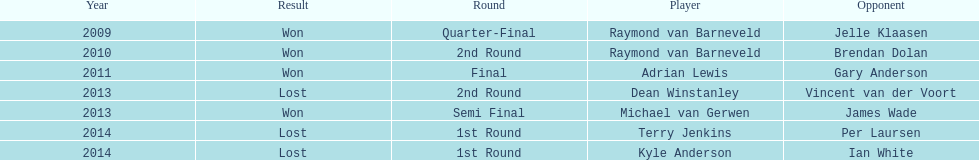Could you parse the entire table as a dict? {'header': ['Year', 'Result', 'Round', 'Player', 'Opponent'], 'rows': [['2009', 'Won', 'Quarter-Final', 'Raymond van Barneveld', 'Jelle Klaasen'], ['2010', 'Won', '2nd Round', 'Raymond van Barneveld', 'Brendan Dolan'], ['2011', 'Won', 'Final', 'Adrian Lewis', 'Gary Anderson'], ['2013', 'Lost', '2nd Round', 'Dean Winstanley', 'Vincent van der Voort'], ['2013', 'Won', 'Semi Final', 'Michael van Gerwen', 'James Wade'], ['2014', 'Lost', '1st Round', 'Terry Jenkins', 'Per Laursen'], ['2014', 'Lost', '1st Round', 'Kyle Anderson', 'Ian White']]} Other than kyle anderson, who else lost in 2014? Terry Jenkins. 